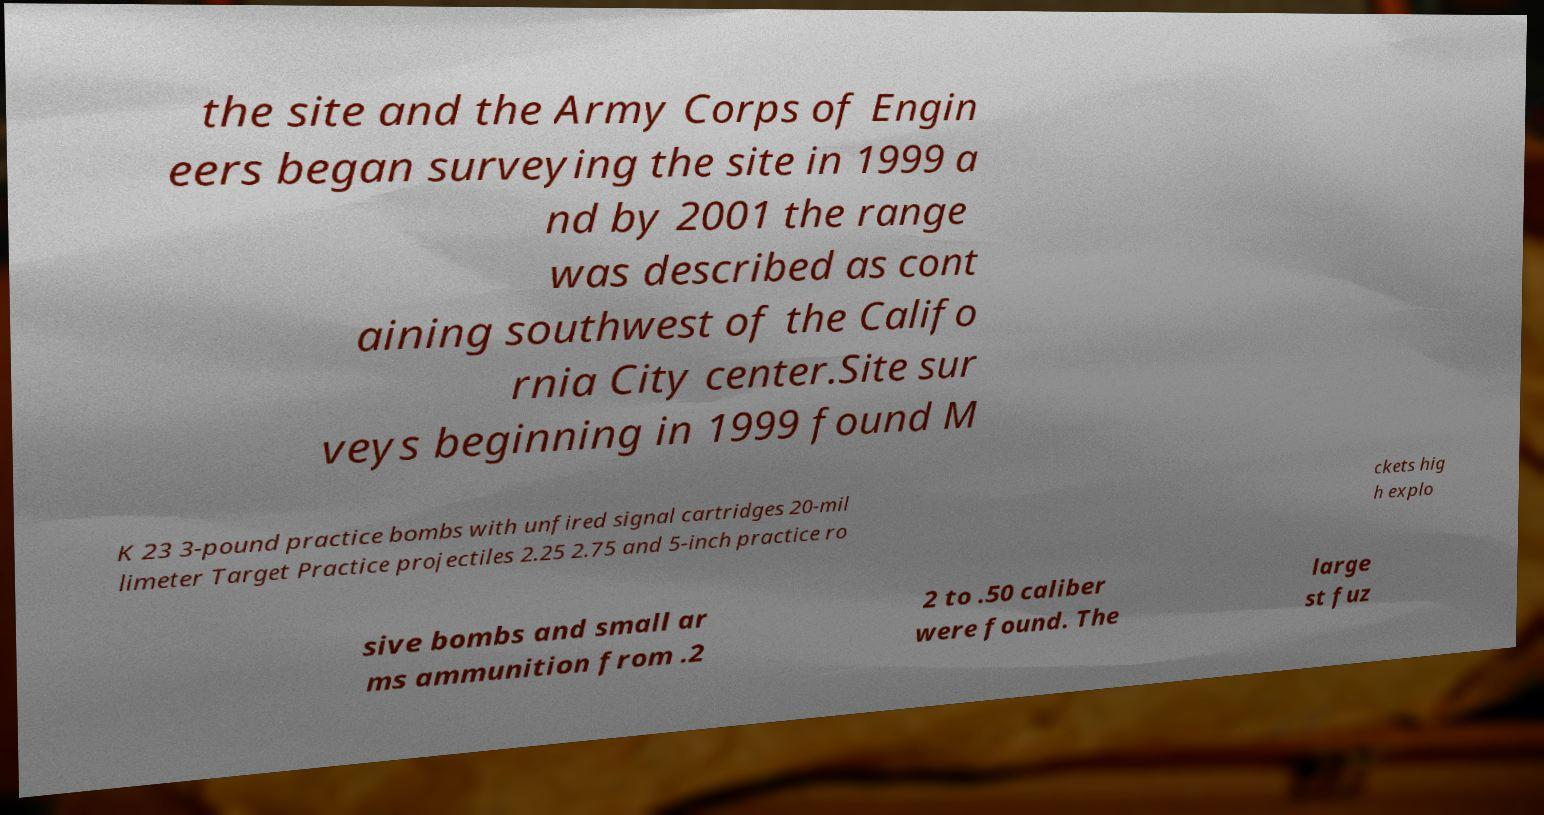There's text embedded in this image that I need extracted. Can you transcribe it verbatim? the site and the Army Corps of Engin eers began surveying the site in 1999 a nd by 2001 the range was described as cont aining southwest of the Califo rnia City center.Site sur veys beginning in 1999 found M K 23 3-pound practice bombs with unfired signal cartridges 20-mil limeter Target Practice projectiles 2.25 2.75 and 5-inch practice ro ckets hig h explo sive bombs and small ar ms ammunition from .2 2 to .50 caliber were found. The large st fuz 